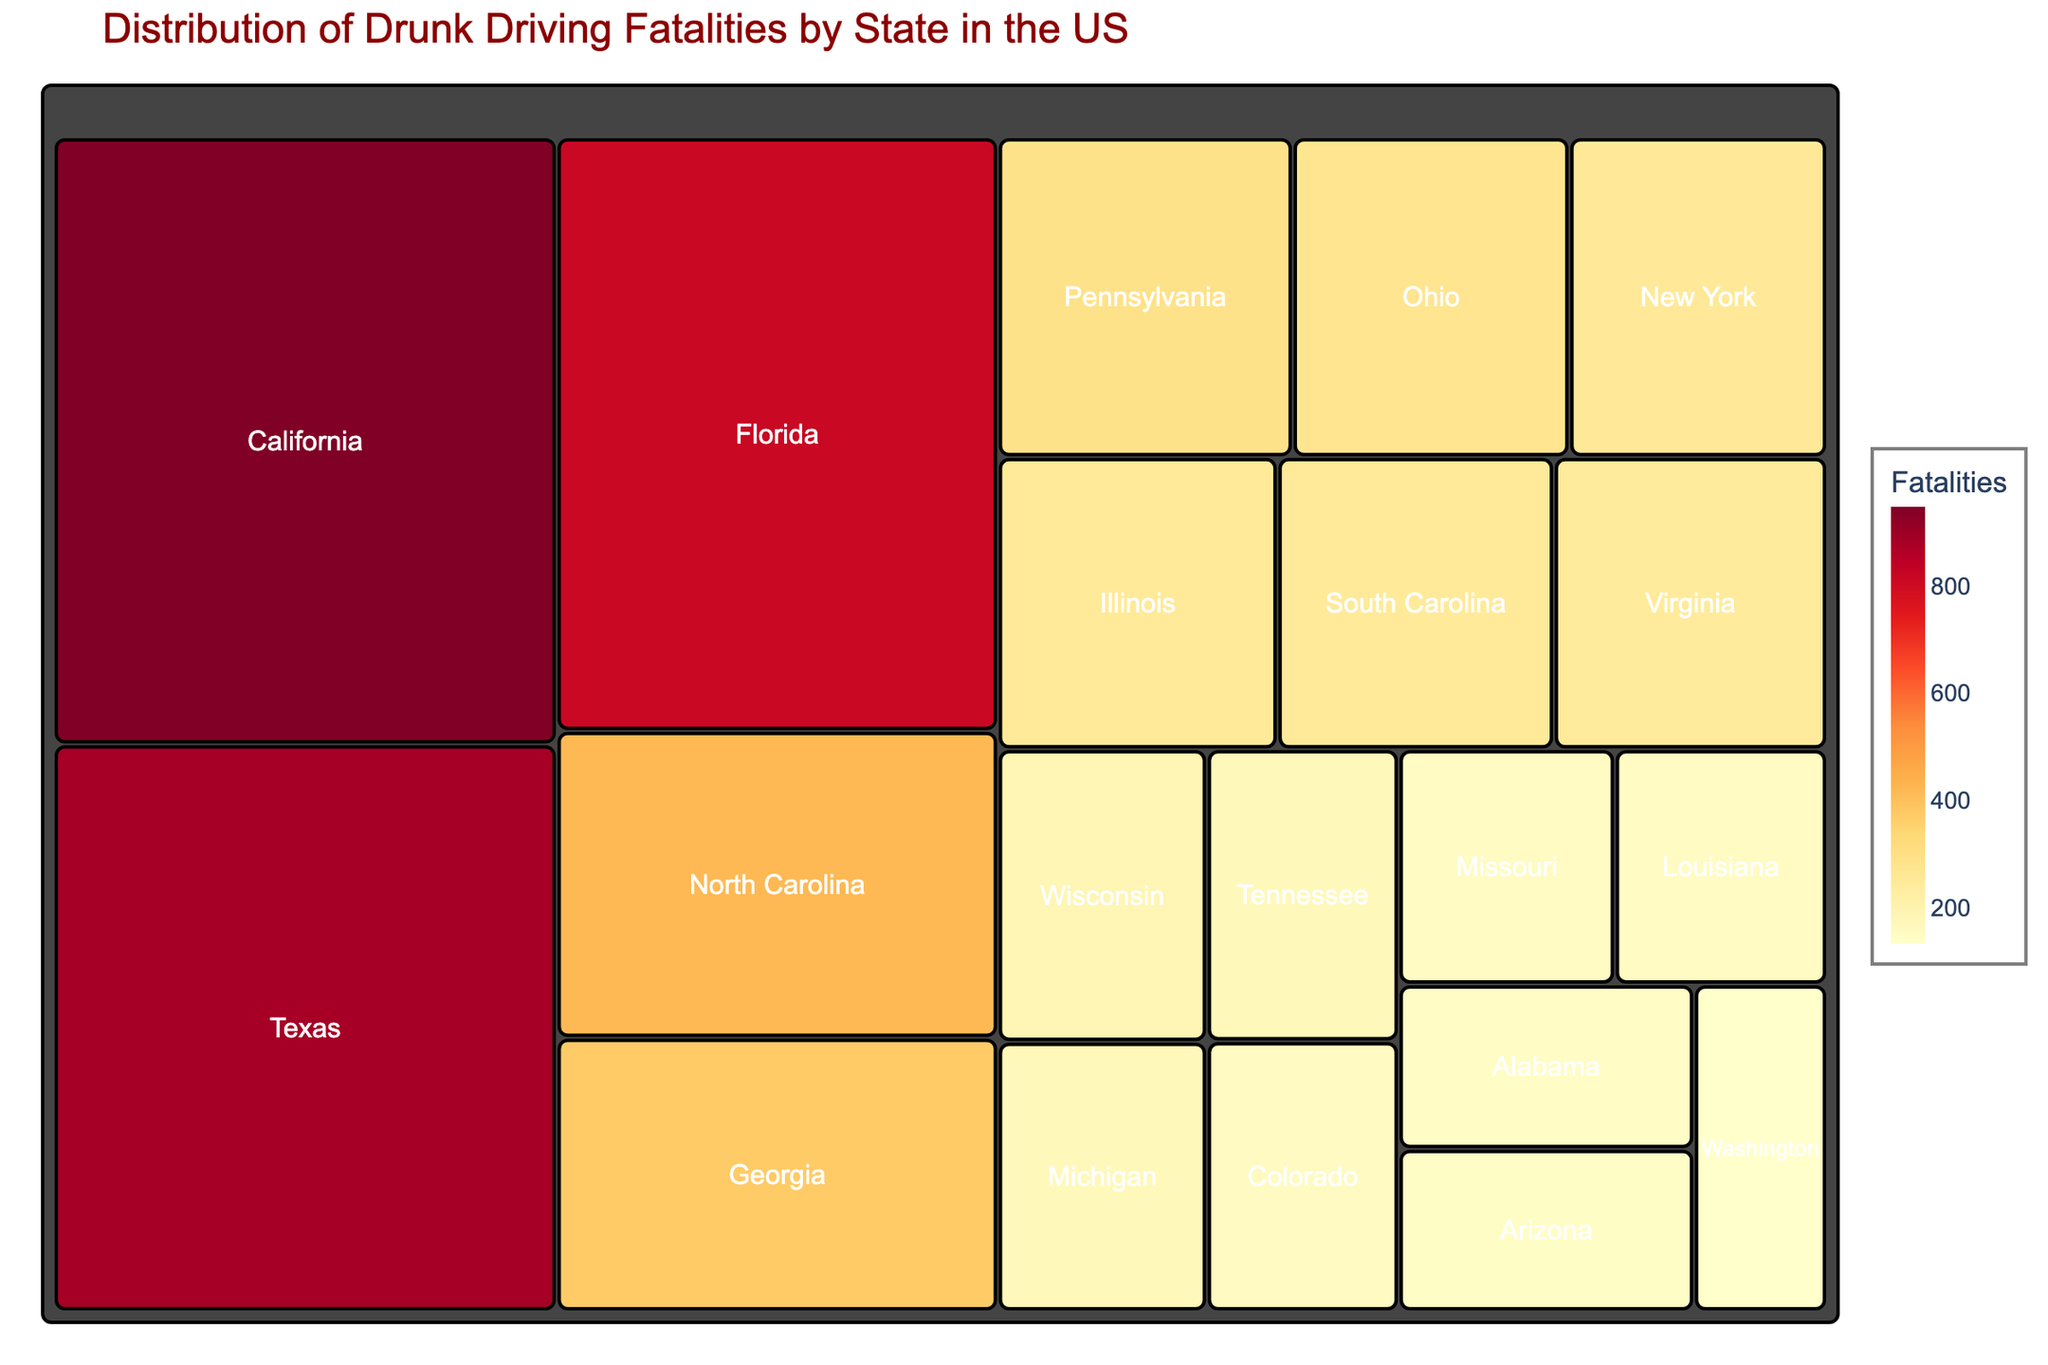What is the title of the treemap? The title of the treemap is shown at the top of the figure, displayed in larger, dark red text.
Answer: Distribution of Drunk Driving Fatalities by State in the US What state has the highest number of drunk driving fatalities? The state with the largest area and darkest color in the treemap indicates the highest number of fatalities.
Answer: California How many drunk driving fatalities are there in Texas? Hover over the area labeled "Texas" and look at the number of fatalities shown.
Answer: 886 Which state has fewer drunk driving fatalities, Georgia or Pennsylvania? Compare the fatalities data displayed when hovering over the areas labeled "Georgia" and "Pennsylvania."
Answer: Pennsylvania What is the total number of drunk driving fatalities in Florida, North Carolina, and Georgia combined? Sum the fatalities of the three states: Florida (814), North Carolina (421), and Georgia (375). 814 + 421 + 375 = 1610
Answer: 1610 What is the average number of drunk driving fatalities among the states listed? Sum the fatalities of all states and divide by the number of states. Total fatalities: 949 + 886 + 814 + 421 + 375 + 293 + 275 + 256 + 254 + 251 + 248 + 190 + 175 + 174 + 161 + 158 + 155 + 151 + 149 + 135 = 6490. Number of states: 20. Average: 6490 / 20 = 324.5
Answer: 324.5 How does the number of drunk driving fatalities in Wisconsin compare to that in Michigan? Compare the fatalities in the two states by hovering over "Wisconsin" (190) and "Michigan" (175).
Answer: Wisconsin has more What percentage of the total fatalities is accounted for by California? Divide the number of fatalities in California (949) by the total fatalities (6490) and multiply by 100. (949 / 6490) * 100 ≈ 14.62%
Answer: ~14.62% Which states have exactly or over 300 fatalities? Identify the states with 300 or more fatalities: California (949), Texas (886), Florida (814), North Carolina (421), Georgia (375), Pennsylvania (293, not over 300).
Answer: California, Texas, Florida, North Carolina, Georgia Are there more drunk driving fatalities in Arizona or Washington? Compare the number of fatalities: Arizona (149) and Washington (135).
Answer: Arizona 